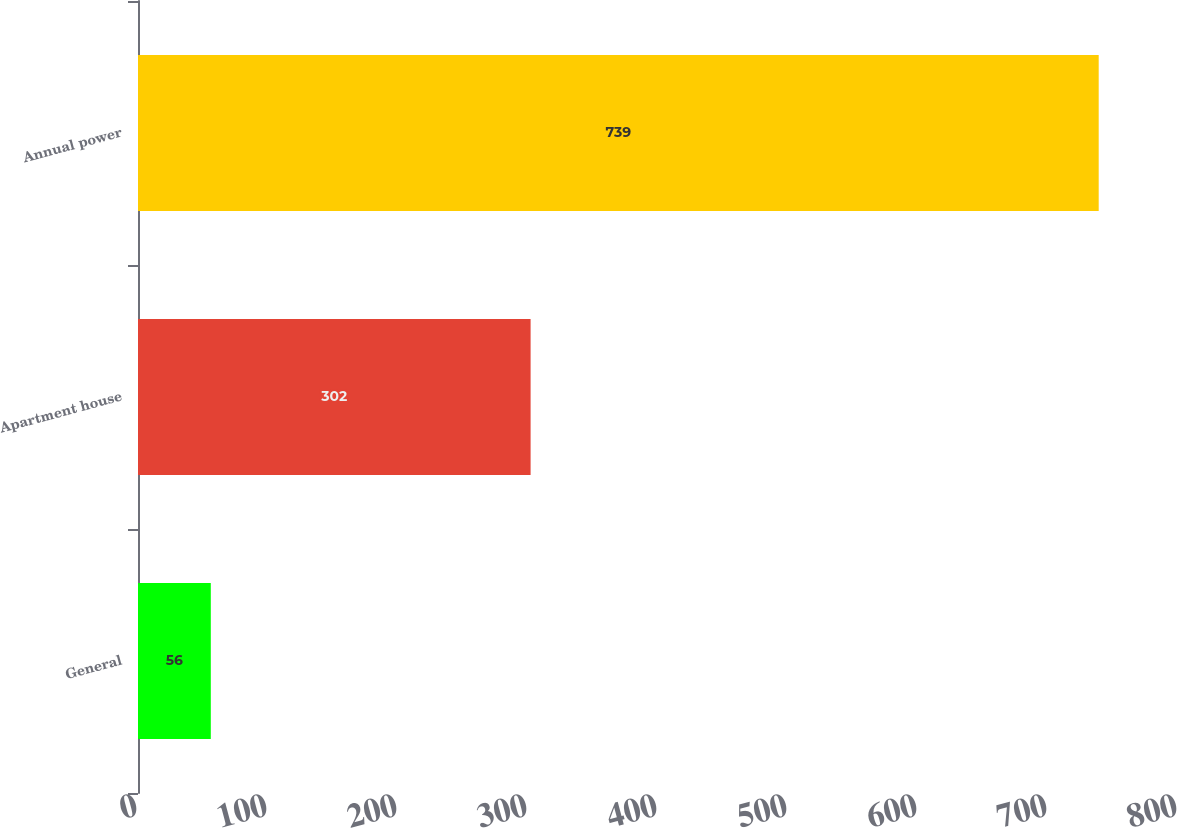Convert chart to OTSL. <chart><loc_0><loc_0><loc_500><loc_500><bar_chart><fcel>General<fcel>Apartment house<fcel>Annual power<nl><fcel>56<fcel>302<fcel>739<nl></chart> 